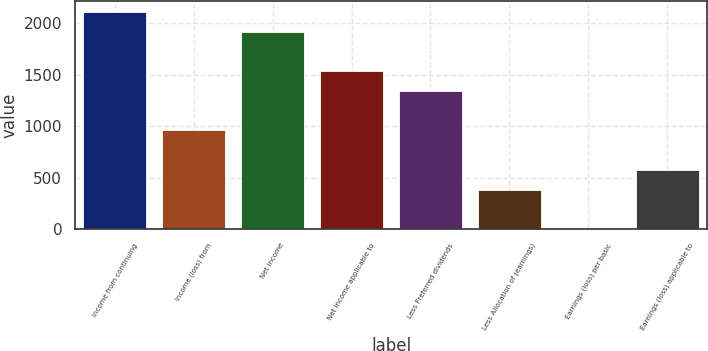Convert chart to OTSL. <chart><loc_0><loc_0><loc_500><loc_500><bar_chart><fcel>Income from continuing<fcel>Income (loss) from<fcel>Net income<fcel>Net income applicable to<fcel>Less Preferred dividends<fcel>Less Allocation of (earnings)<fcel>Earnings (loss) per basic<fcel>Earnings (loss) applicable to<nl><fcel>2110.92<fcel>959.52<fcel>1919.02<fcel>1535.22<fcel>1343.32<fcel>383.82<fcel>0.02<fcel>575.72<nl></chart> 